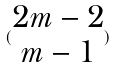<formula> <loc_0><loc_0><loc_500><loc_500>( \begin{matrix} 2 m - 2 \\ m - 1 \end{matrix} )</formula> 